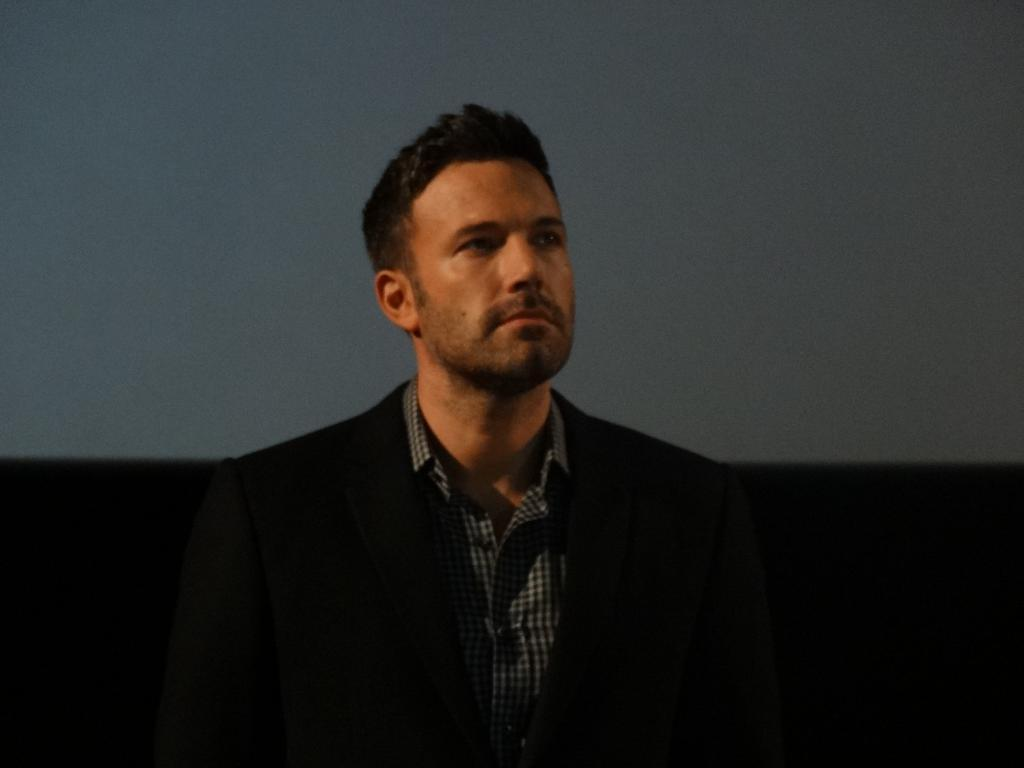What is the main subject of the image? There is a person in the image. Can you describe the person's attire? The person is wearing clothes. What type of straw is the person using to navigate the voyage in the image? There is no straw or voyage present in the image; it only features a person wearing clothes. 